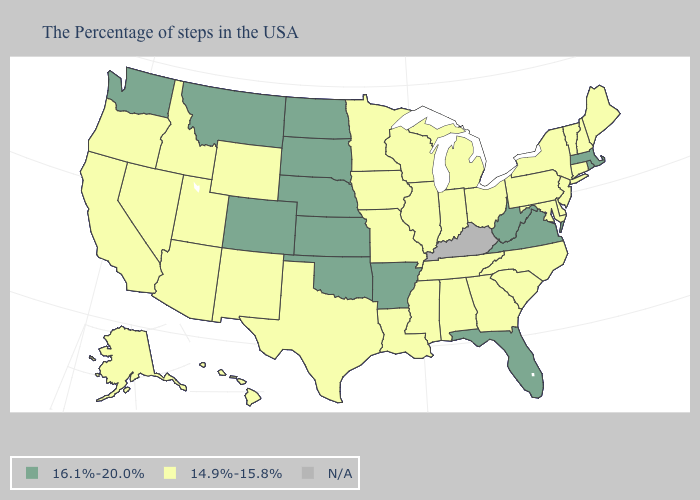What is the value of Nevada?
Answer briefly. 14.9%-15.8%. What is the value of Arkansas?
Short answer required. 16.1%-20.0%. Among the states that border Mississippi , which have the lowest value?
Give a very brief answer. Alabama, Tennessee, Louisiana. Among the states that border Connecticut , which have the highest value?
Concise answer only. Massachusetts, Rhode Island. Name the states that have a value in the range 14.9%-15.8%?
Quick response, please. Maine, New Hampshire, Vermont, Connecticut, New York, New Jersey, Delaware, Maryland, Pennsylvania, North Carolina, South Carolina, Ohio, Georgia, Michigan, Indiana, Alabama, Tennessee, Wisconsin, Illinois, Mississippi, Louisiana, Missouri, Minnesota, Iowa, Texas, Wyoming, New Mexico, Utah, Arizona, Idaho, Nevada, California, Oregon, Alaska, Hawaii. Is the legend a continuous bar?
Quick response, please. No. Name the states that have a value in the range 14.9%-15.8%?
Write a very short answer. Maine, New Hampshire, Vermont, Connecticut, New York, New Jersey, Delaware, Maryland, Pennsylvania, North Carolina, South Carolina, Ohio, Georgia, Michigan, Indiana, Alabama, Tennessee, Wisconsin, Illinois, Mississippi, Louisiana, Missouri, Minnesota, Iowa, Texas, Wyoming, New Mexico, Utah, Arizona, Idaho, Nevada, California, Oregon, Alaska, Hawaii. What is the lowest value in states that border Washington?
Be succinct. 14.9%-15.8%. Does Virginia have the highest value in the South?
Give a very brief answer. Yes. What is the highest value in the USA?
Give a very brief answer. 16.1%-20.0%. Name the states that have a value in the range N/A?
Give a very brief answer. Kentucky. What is the value of Illinois?
Quick response, please. 14.9%-15.8%. How many symbols are there in the legend?
Answer briefly. 3. 